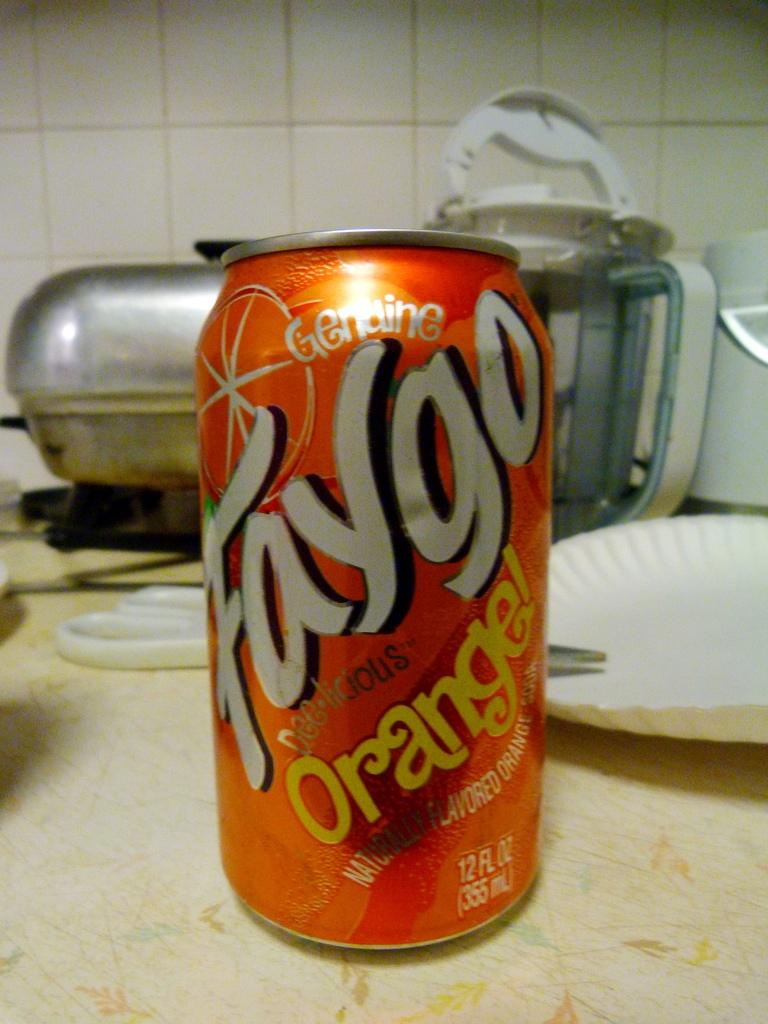<image>
Relay a brief, clear account of the picture shown. The very dated counter top has a can of Faygo orange soda sitting on it. 